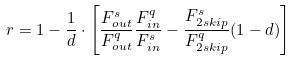Convert formula to latex. <formula><loc_0><loc_0><loc_500><loc_500>r = 1 - \frac { 1 } { d } \cdot \left [ { \frac { F _ { o u t } ^ { s } } { F _ { o u t } ^ { q } } \frac { F _ { i n } ^ { q } } { F _ { i n } ^ { s } } - \frac { F _ { 2 s k i p } ^ { s } } { F _ { 2 s k i p } ^ { q } } ( 1 - d ) } \right ]</formula> 